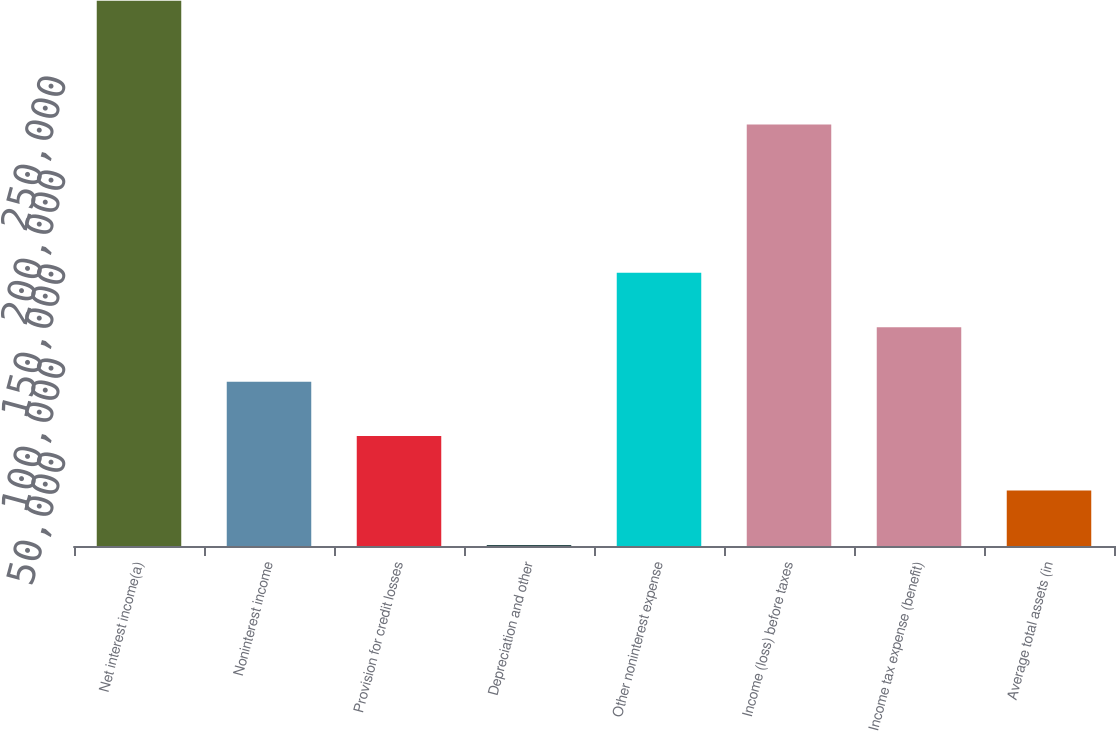<chart> <loc_0><loc_0><loc_500><loc_500><bar_chart><fcel>Net interest income(a)<fcel>Noninterest income<fcel>Provision for credit losses<fcel>Depreciation and other<fcel>Other noninterest expense<fcel>Income (loss) before taxes<fcel>Income tax expense (benefit)<fcel>Average total assets (in<nl><fcel>289992<fcel>87395.9<fcel>58453.6<fcel>569<fcel>145280<fcel>224167<fcel>116338<fcel>29511.3<nl></chart> 